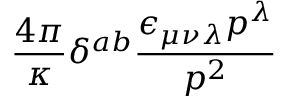Convert formula to latex. <formula><loc_0><loc_0><loc_500><loc_500>\frac { 4 \pi } { \kappa } \delta ^ { a b } \frac { \epsilon _ { \mu \nu \lambda } p ^ { \lambda } } { p ^ { 2 } }</formula> 